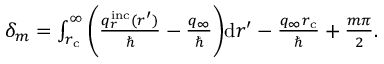<formula> <loc_0><loc_0><loc_500><loc_500>\begin{array} { r } { \delta _ { m } = \int _ { r _ { c } } ^ { \infty } \left ( \frac { q _ { r } ^ { i n c } ( r ^ { \prime } ) } { } - \frac { q _ { \infty } } { } \right ) d r ^ { \prime } - \frac { q _ { \infty } r _ { c } } { } + \frac { m \pi } { 2 } . } \end{array}</formula> 